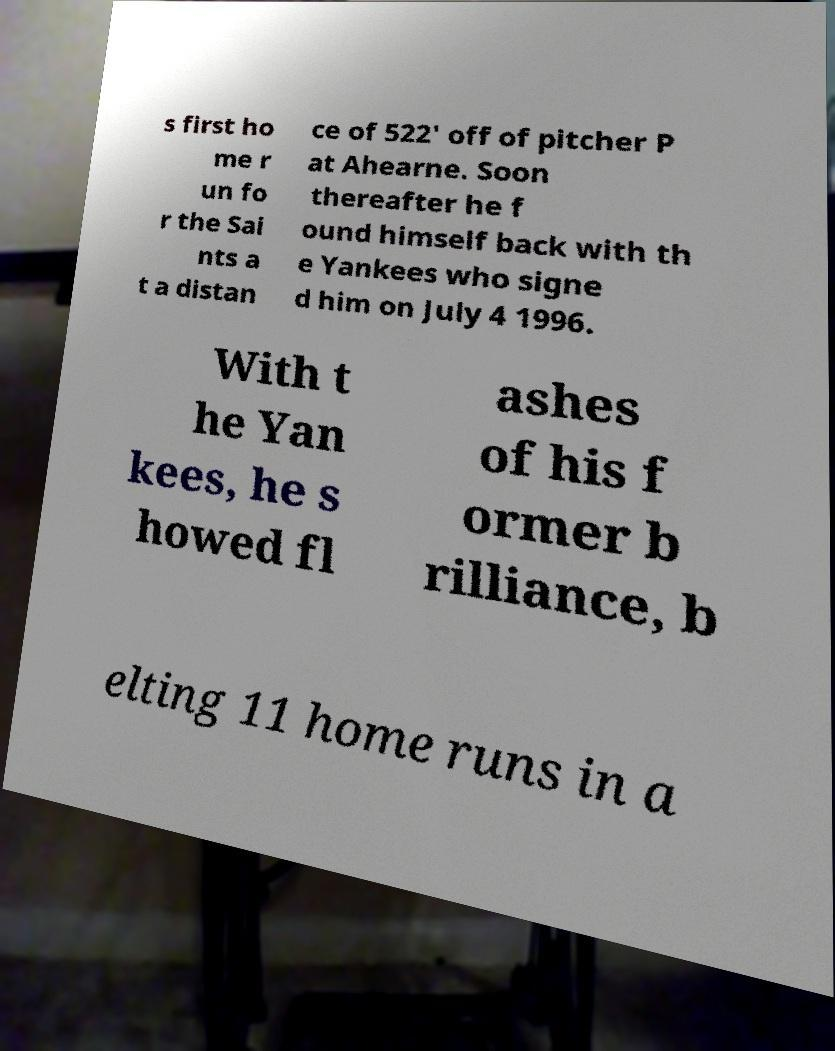Could you extract and type out the text from this image? s first ho me r un fo r the Sai nts a t a distan ce of 522' off of pitcher P at Ahearne. Soon thereafter he f ound himself back with th e Yankees who signe d him on July 4 1996. With t he Yan kees, he s howed fl ashes of his f ormer b rilliance, b elting 11 home runs in a 